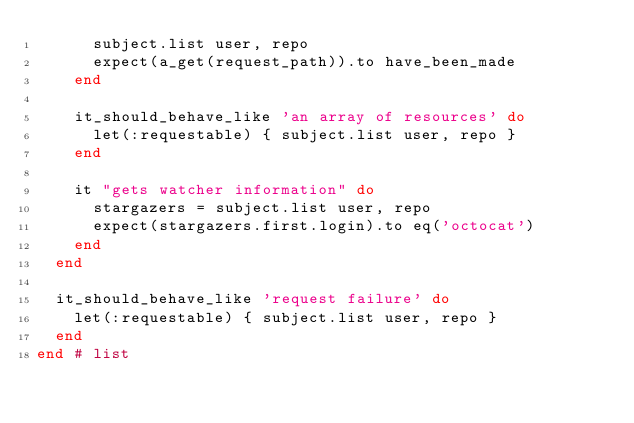<code> <loc_0><loc_0><loc_500><loc_500><_Ruby_>      subject.list user, repo
      expect(a_get(request_path)).to have_been_made
    end

    it_should_behave_like 'an array of resources' do
      let(:requestable) { subject.list user, repo }
    end

    it "gets watcher information" do
      stargazers = subject.list user, repo
      expect(stargazers.first.login).to eq('octocat')
    end
  end

  it_should_behave_like 'request failure' do
    let(:requestable) { subject.list user, repo }
  end
end # list
</code> 